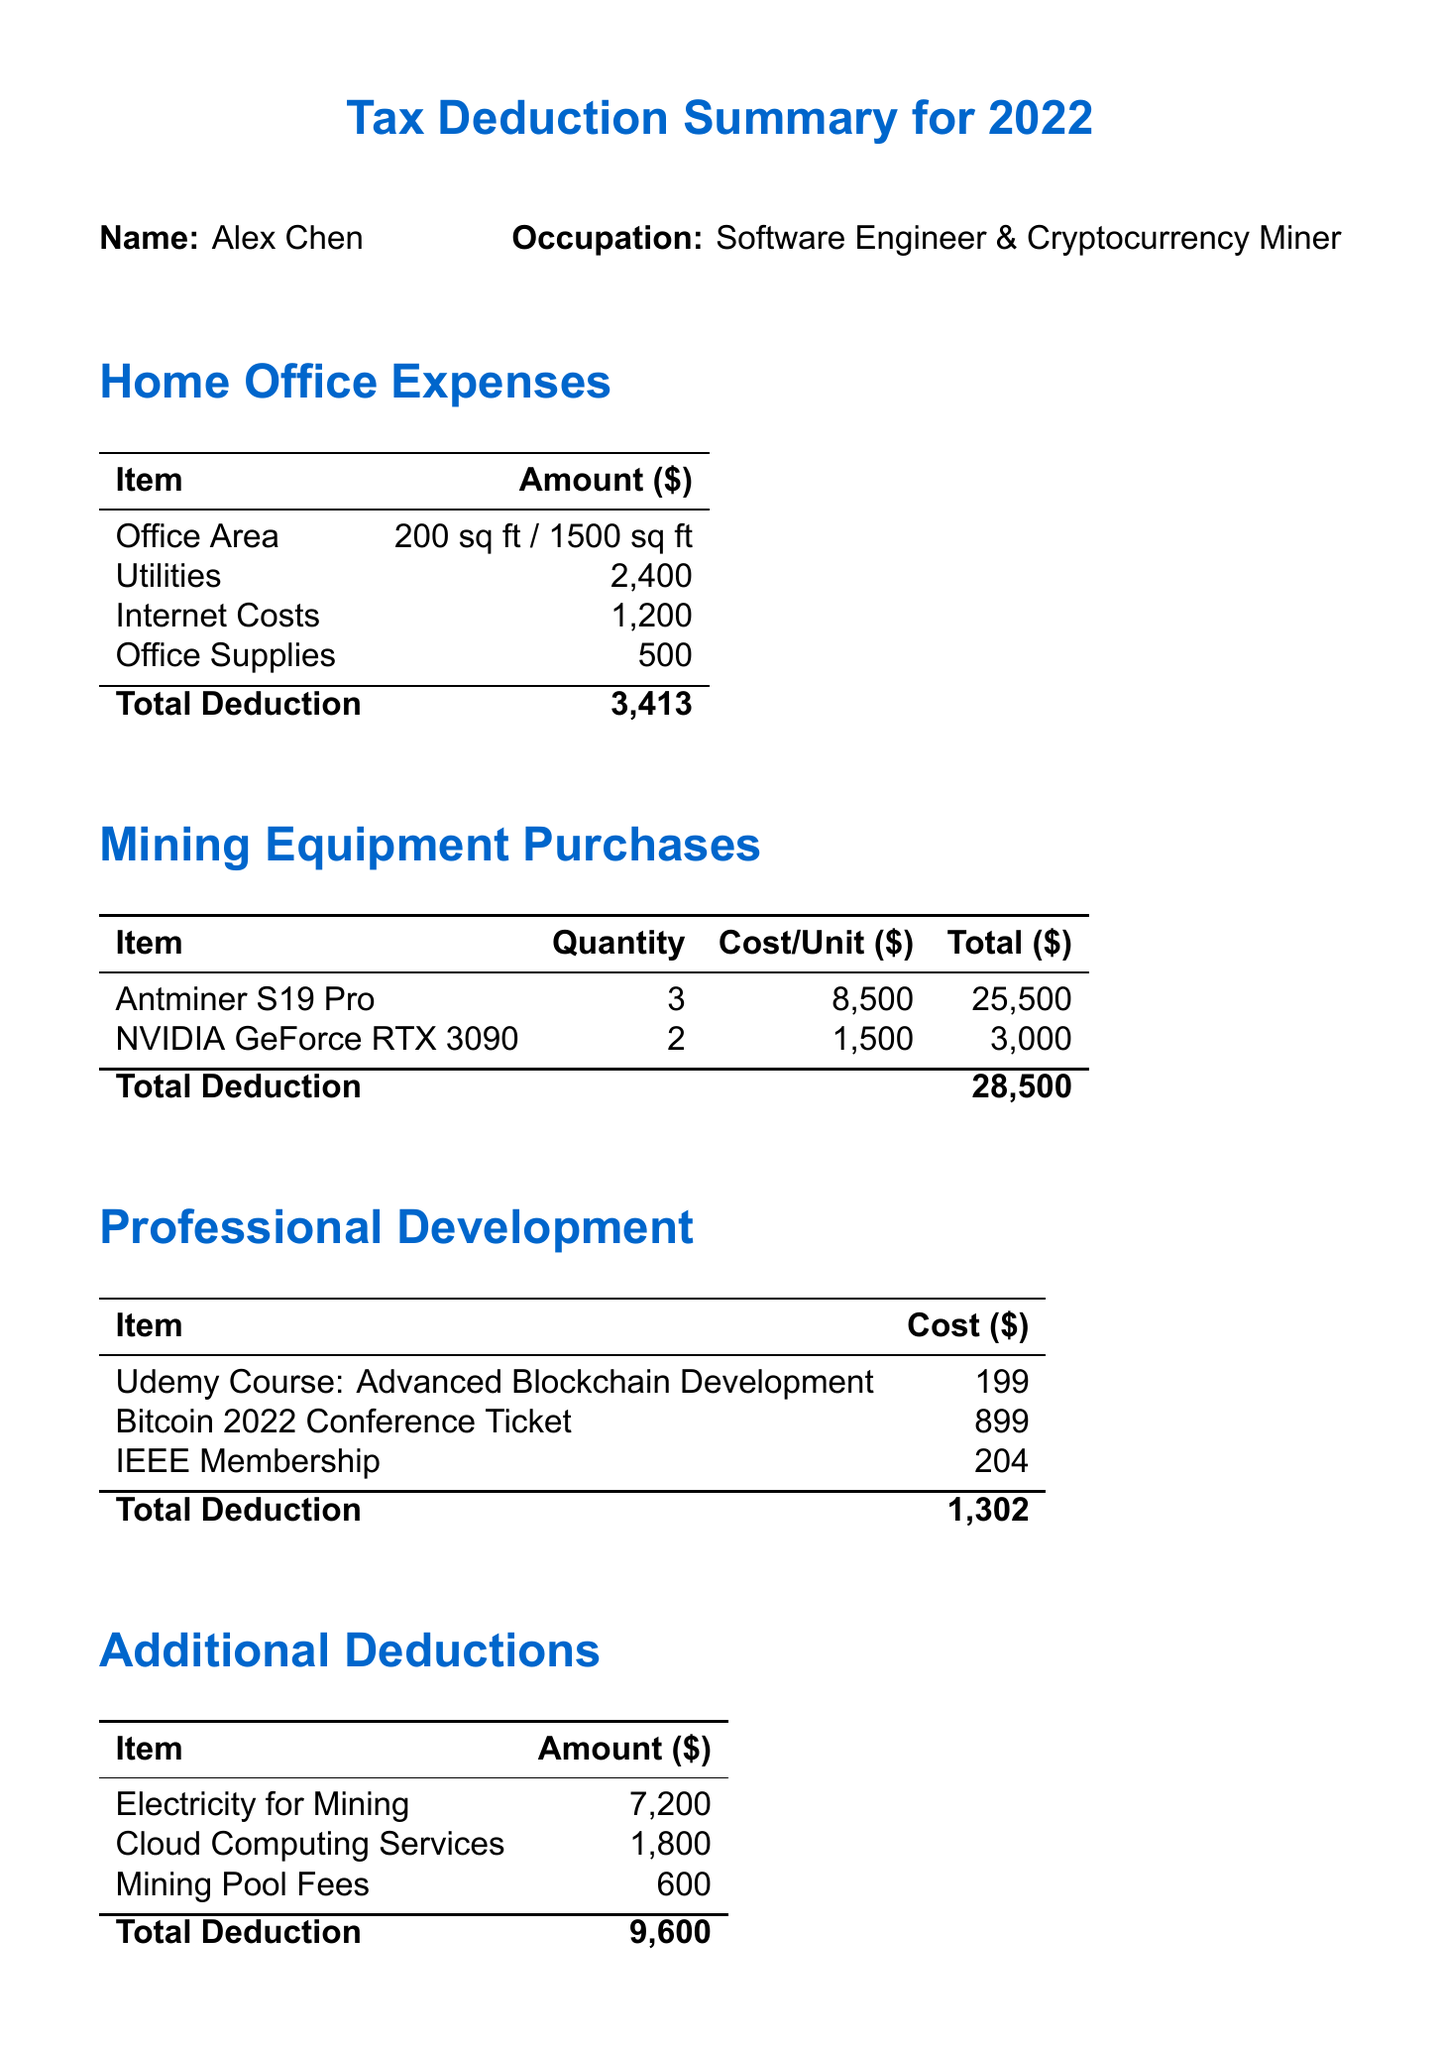what is the total deduction for home office expenses? The total deduction for home office expenses is listed in the document under the home office expenses section.
Answer: 3413 how many Antminer S19 Pro units were purchased? The document specifies that three units of Antminer S19 Pro were bought under the mining equipment purchases section.
Answer: 3 what is the total cost for professional development deductions? The total cost for professional development deductions can be found in the professional development section of the document.
Answer: 1302 what is the total amount spent on electricity for mining? The document provides the specific cost for electricity for mining under the additional deductions section.
Answer: 7200 who is the owner of the tax deduction summary? The document states the name of the individual at the beginning of the summary.
Answer: Alex Chen what is the quantity of NVIDIA GeForce RTX 3090 purchased? The document lists the details of mining equipment purchases, including the quantity of NVIDIA GeForce RTX 3090.
Answer: 2 what is the total deduction amount for mining equipment? The total deduction for mining equipment purchases is given in the mining equipment section of the document.
Answer: 28500 how much was spent on cloud computing services? The document includes a line item for cloud computing services under the additional deductions section, indicating the expenditure.
Answer: 1800 what is the grand total of all deductions? The grand total is calculated based on all individual deductions listed in the final summary section of the document.
Answer: 42815 